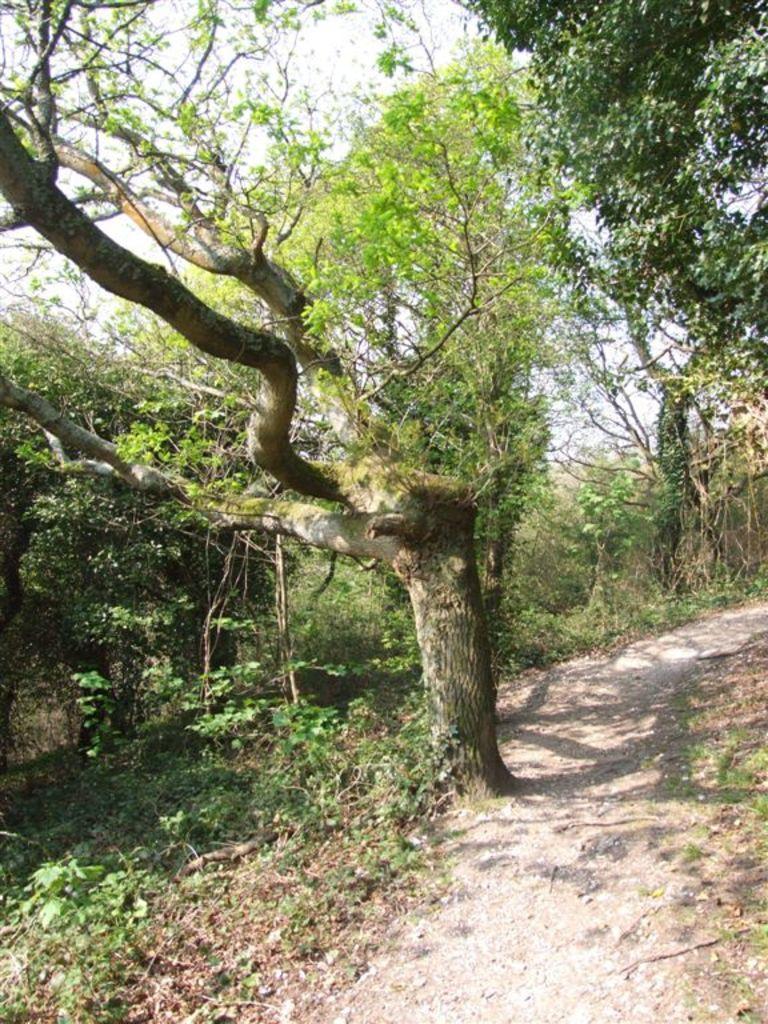How would you summarize this image in a sentence or two? In this picture we can see trees, at the bottom there are plants, we can see the sky at the top of the picture. 